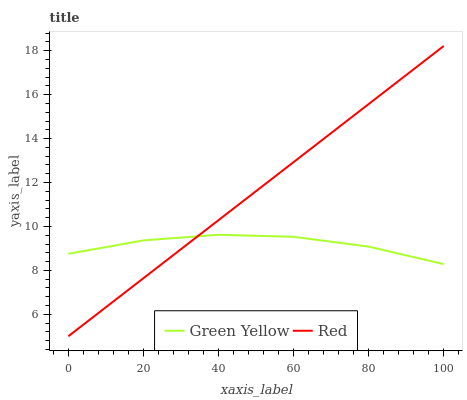Does Green Yellow have the minimum area under the curve?
Answer yes or no. Yes. Does Red have the maximum area under the curve?
Answer yes or no. Yes. Does Red have the minimum area under the curve?
Answer yes or no. No. Is Red the smoothest?
Answer yes or no. Yes. Is Green Yellow the roughest?
Answer yes or no. Yes. Is Red the roughest?
Answer yes or no. No. Does Red have the highest value?
Answer yes or no. Yes. Does Red intersect Green Yellow?
Answer yes or no. Yes. Is Red less than Green Yellow?
Answer yes or no. No. Is Red greater than Green Yellow?
Answer yes or no. No. 